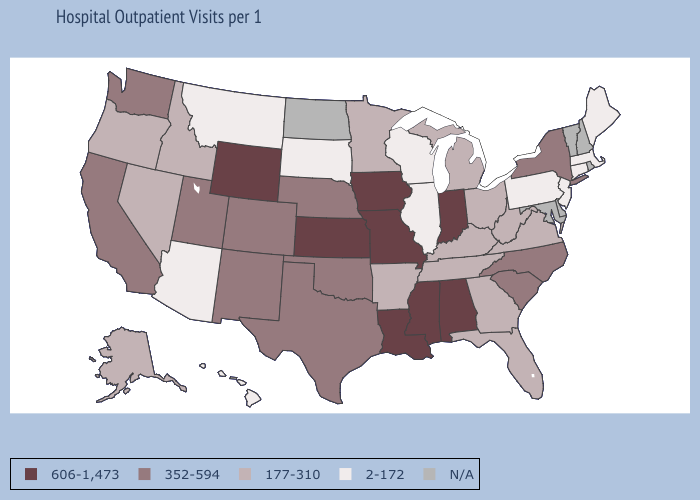What is the value of Kentucky?
Concise answer only. 177-310. What is the value of Delaware?
Concise answer only. N/A. Does Oklahoma have the highest value in the USA?
Keep it brief. No. Which states hav the highest value in the West?
Concise answer only. Wyoming. What is the value of Utah?
Give a very brief answer. 352-594. Which states have the highest value in the USA?
Short answer required. Alabama, Indiana, Iowa, Kansas, Louisiana, Mississippi, Missouri, Wyoming. Name the states that have a value in the range N/A?
Write a very short answer. Delaware, Maryland, New Hampshire, North Dakota, Rhode Island, Vermont. Which states have the highest value in the USA?
Give a very brief answer. Alabama, Indiana, Iowa, Kansas, Louisiana, Mississippi, Missouri, Wyoming. What is the lowest value in the USA?
Short answer required. 2-172. Does the first symbol in the legend represent the smallest category?
Concise answer only. No. Name the states that have a value in the range 352-594?
Be succinct. California, Colorado, Nebraska, New Mexico, New York, North Carolina, Oklahoma, South Carolina, Texas, Utah, Washington. What is the value of Oklahoma?
Concise answer only. 352-594. Name the states that have a value in the range 606-1,473?
Write a very short answer. Alabama, Indiana, Iowa, Kansas, Louisiana, Mississippi, Missouri, Wyoming. Does Colorado have the lowest value in the West?
Answer briefly. No. 